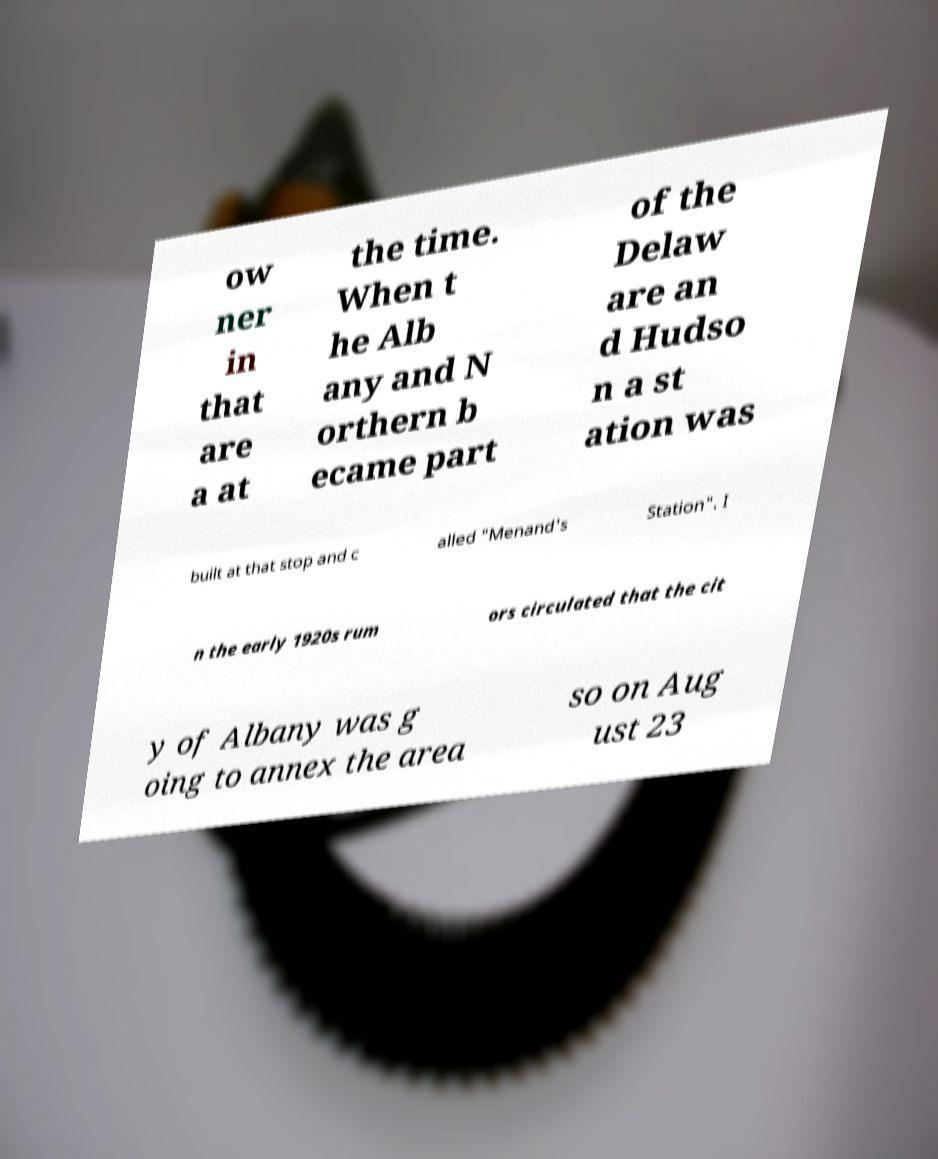There's text embedded in this image that I need extracted. Can you transcribe it verbatim? ow ner in that are a at the time. When t he Alb any and N orthern b ecame part of the Delaw are an d Hudso n a st ation was built at that stop and c alled "Menand's Station". I n the early 1920s rum ors circulated that the cit y of Albany was g oing to annex the area so on Aug ust 23 